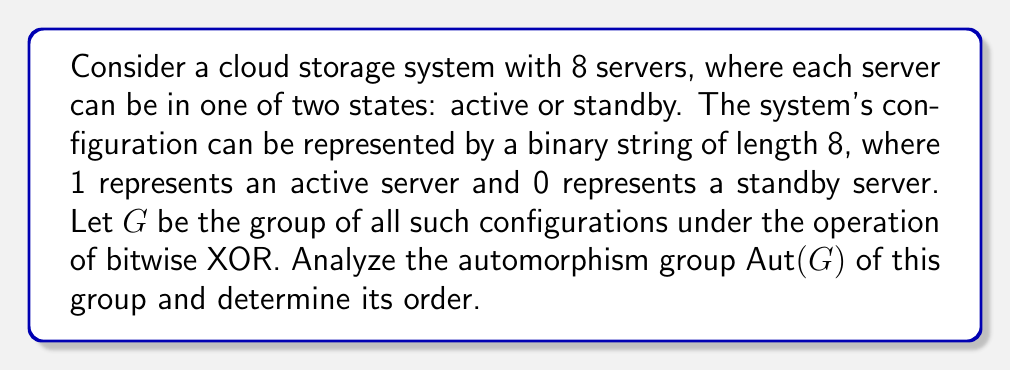Teach me how to tackle this problem. To analyze the automorphism group of $G$, let's follow these steps:

1) First, we need to understand the structure of $G$:
   - $G$ is isomorphic to $(\mathbb{Z}_2)^8$, the direct product of 8 copies of $\mathbb{Z}_2$.
   - $G$ has $2^8 = 256$ elements.
   - $G$ is an elementary abelian 2-group.

2) For an elementary abelian 2-group of rank $n$, the automorphism group is isomorphic to $GL(n, \mathbb{F}_2)$, the general linear group of $n \times n$ invertible matrices over the field $\mathbb{F}_2$.

3) In our case, $n = 8$, so $\text{Aut}(G) \cong GL(8, \mathbb{F}_2)$.

4) To find the order of $GL(8, \mathbb{F}_2)$, we use the following formula:
   $$|GL(n, \mathbb{F}_q)| = (q^n - 1)(q^n - q)(q^n - q^2)\cdots(q^n - q^{n-1})$$

5) Substituting $n = 8$ and $q = 2$:
   $$|GL(8, \mathbb{F}_2)| = (2^8 - 1)(2^8 - 2)(2^8 - 2^2)(2^8 - 2^3)(2^8 - 2^4)(2^8 - 2^5)(2^8 - 2^6)(2^8 - 2^7)$$

6) Simplifying:
   $$|GL(8, \mathbb{F}_2)| = 255 \times 254 \times 252 \times 248 \times 240 \times 224 \times 192 \times 128$$

7) Computing this product:
   $$|GL(8, \mathbb{F}_2)| = 5,348,063,769,211,699,200$$

Therefore, the order of $\text{Aut}(G)$ is 5,348,063,769,211,699,200.
Answer: The automorphism group $\text{Aut}(G)$ is isomorphic to $GL(8, \mathbb{F}_2)$, and its order is 5,348,063,769,211,699,200. 